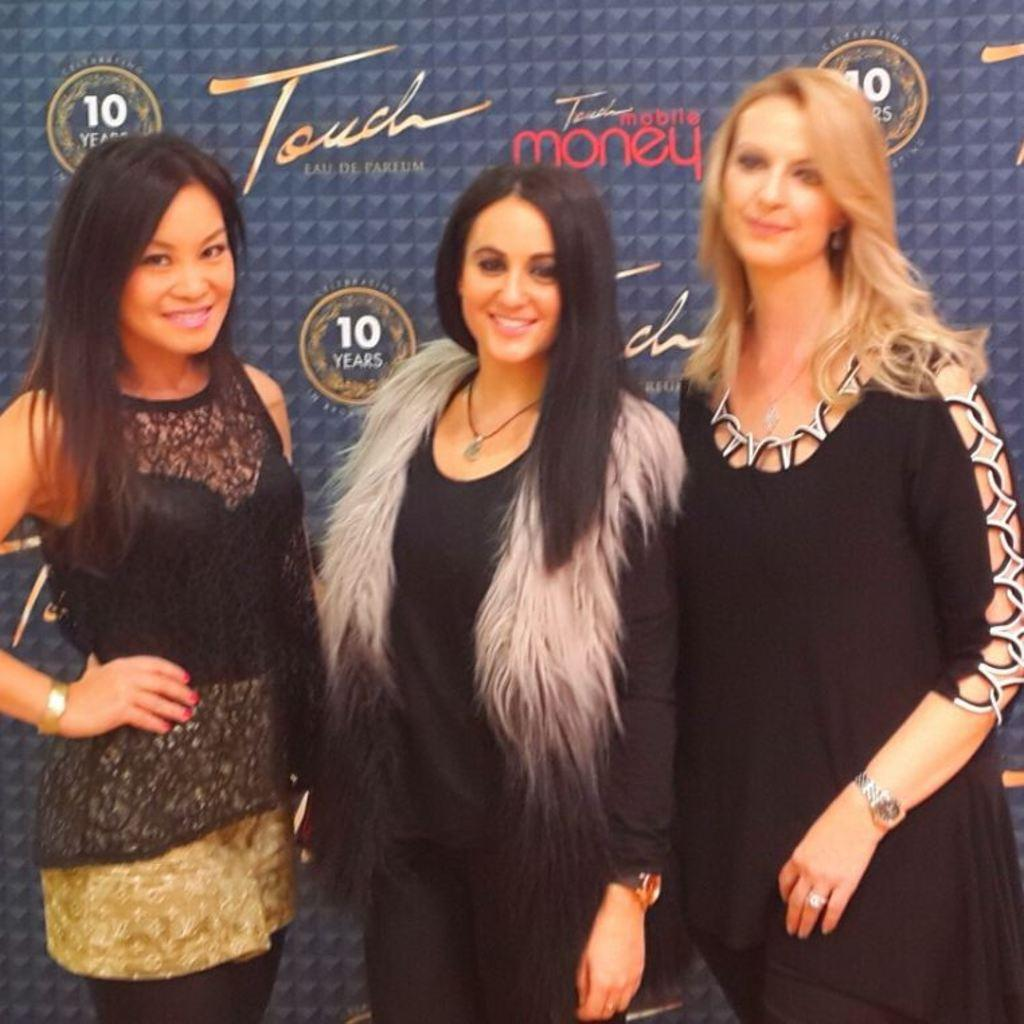How many women are present in the image? There are three women in the image. What are the women wearing? The women are wearing black dresses. What can be seen in the background of the image? There is a banner in the background of the image. What type of authority figure can be seen in the image? There is no authority figure present in the image; it features three women wearing black dresses and a banner in the background. 